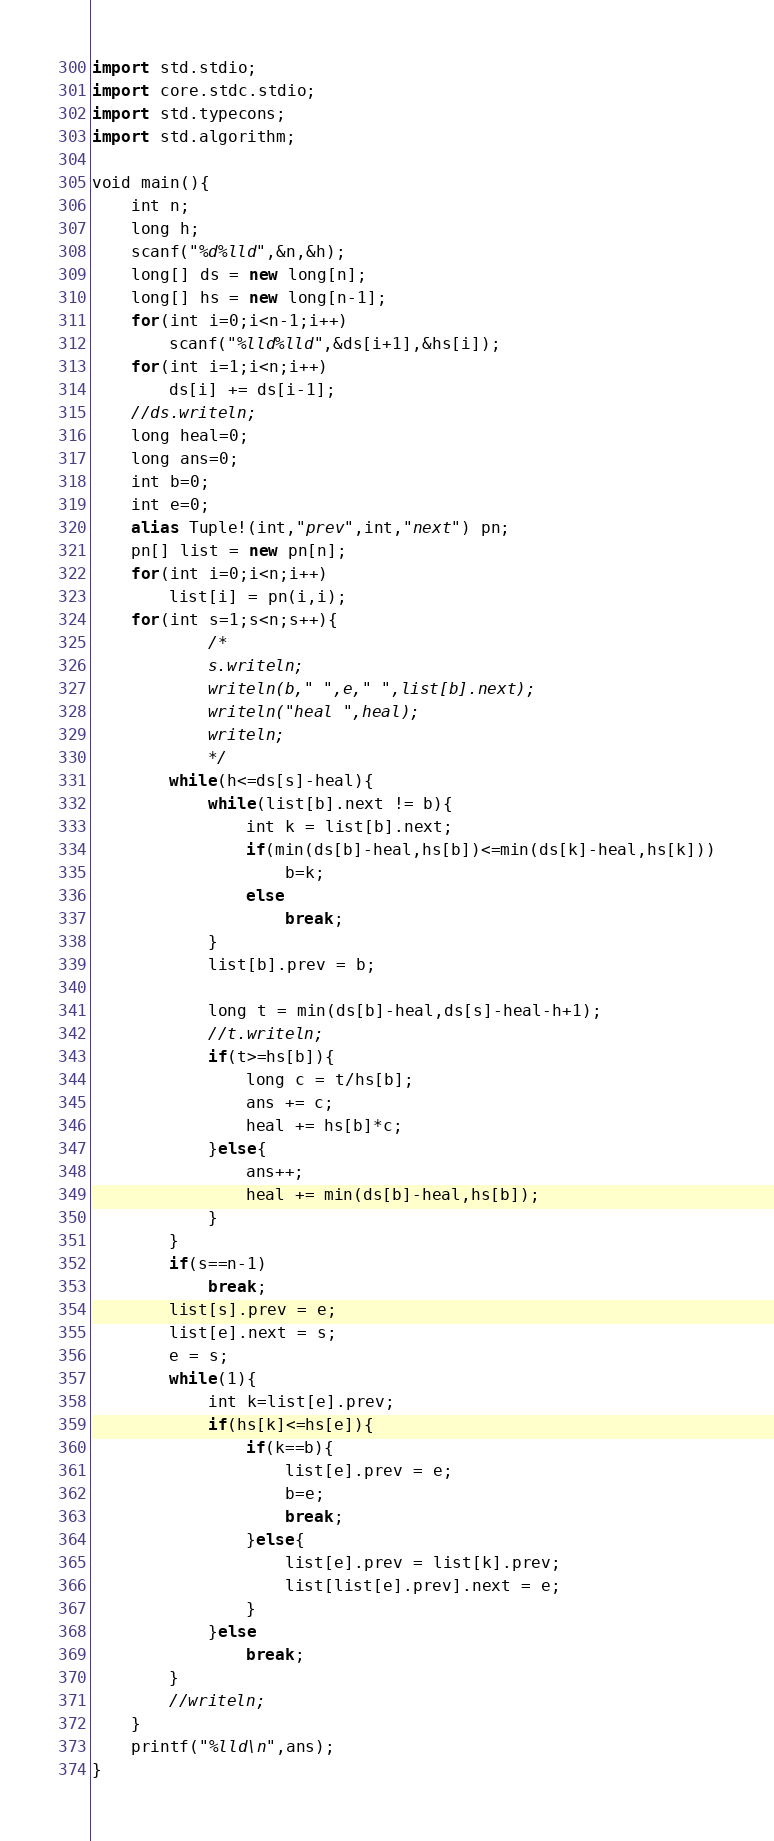Convert code to text. <code><loc_0><loc_0><loc_500><loc_500><_D_>import std.stdio;
import core.stdc.stdio;
import std.typecons;
import std.algorithm;

void main(){
	int n;
	long h;
	scanf("%d%lld",&n,&h);
	long[] ds = new long[n];
	long[] hs = new long[n-1];
	for(int i=0;i<n-1;i++)
		scanf("%lld%lld",&ds[i+1],&hs[i]);
	for(int i=1;i<n;i++)
		ds[i] += ds[i-1];
	//ds.writeln;
	long heal=0;
	long ans=0;
	int b=0;
	int e=0;
	alias Tuple!(int,"prev",int,"next") pn;
	pn[] list = new pn[n];
	for(int i=0;i<n;i++)
		list[i] = pn(i,i);
	for(int s=1;s<n;s++){
			/*
			s.writeln;
			writeln(b," ",e," ",list[b].next);
			writeln("heal ",heal);
			writeln;
			*/
		while(h<=ds[s]-heal){
			while(list[b].next != b){
				int k = list[b].next;
				if(min(ds[b]-heal,hs[b])<=min(ds[k]-heal,hs[k]))
					b=k;
				else
					break;
			}
			list[b].prev = b;
			
			long t = min(ds[b]-heal,ds[s]-heal-h+1);
			//t.writeln;	
			if(t>=hs[b]){
				long c = t/hs[b];
				ans += c;
				heal += hs[b]*c;
			}else{
				ans++;
				heal += min(ds[b]-heal,hs[b]);
			}
		}
		if(s==n-1)
			break;
		list[s].prev = e;
		list[e].next = s;
		e = s;
		while(1){
			int k=list[e].prev;
			if(hs[k]<=hs[e]){
				if(k==b){
					list[e].prev = e;
					b=e;
					break;
				}else{
					list[e].prev = list[k].prev;
					list[list[e].prev].next = e;
				}
			}else
				break;
		}
		//writeln;
	}
	printf("%lld\n",ans);
}</code> 